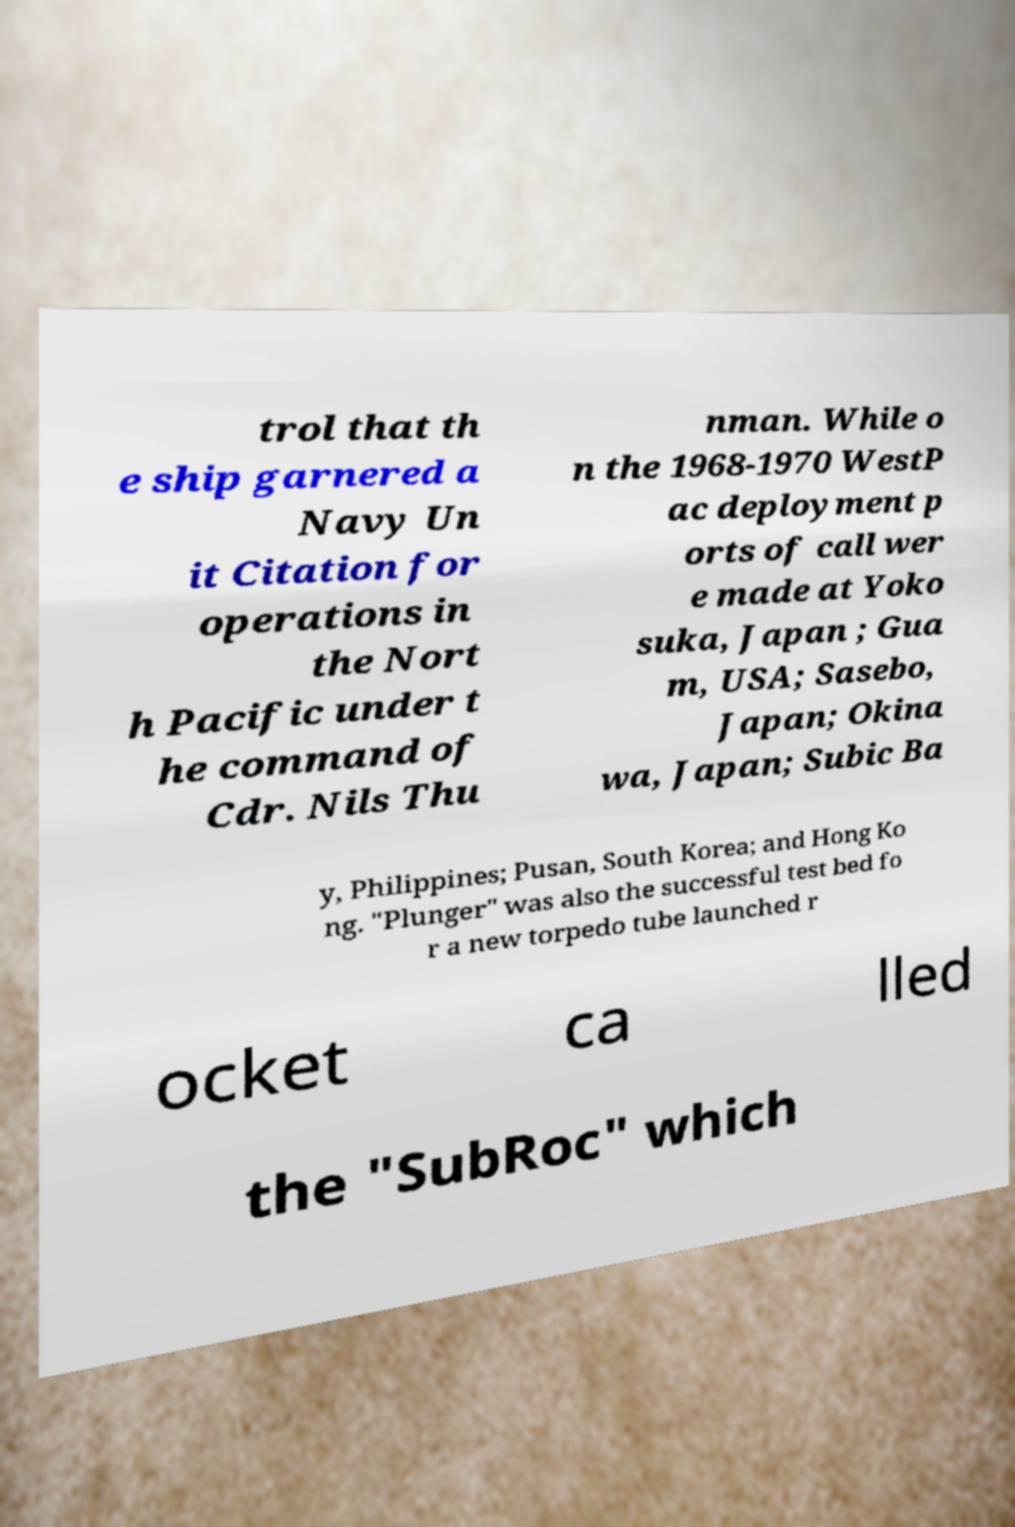There's text embedded in this image that I need extracted. Can you transcribe it verbatim? trol that th e ship garnered a Navy Un it Citation for operations in the Nort h Pacific under t he command of Cdr. Nils Thu nman. While o n the 1968-1970 WestP ac deployment p orts of call wer e made at Yoko suka, Japan ; Gua m, USA; Sasebo, Japan; Okina wa, Japan; Subic Ba y, Philippines; Pusan, South Korea; and Hong Ko ng. "Plunger" was also the successful test bed fo r a new torpedo tube launched r ocket ca lled the "SubRoc" which 